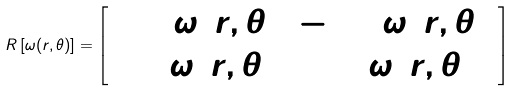<formula> <loc_0><loc_0><loc_500><loc_500>R \left [ \omega ( r , \theta ) \right ] = \left [ \begin{array} { c c } \cos { \omega ( r , \theta ) } & - \sin { \omega ( r , \theta ) } \\ \sin { \omega ( r , \theta ) } & \cos { \omega ( r , \theta ) } \end{array} \right ]</formula> 